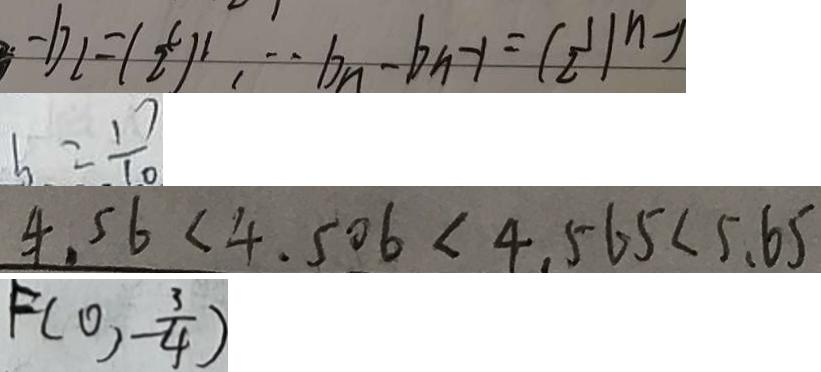<formula> <loc_0><loc_0><loc_500><loc_500>- b _ { 2 } = ( \frac { c } { 2 } ) ^ { 2 } , \cdot b _ { n } - b _ { n } - 1 = ( \frac { 1 } { 2 } ) ^ { n - 1 } 
 b = \frac { 1 7 } { 1 0 } 
 4 . 5 6 < 4 . 5 0 6 < 4 . 5 6 5 < 5 . 6 5 
 F ( 0 , - \frac { 3 } { 4 } )</formula> 